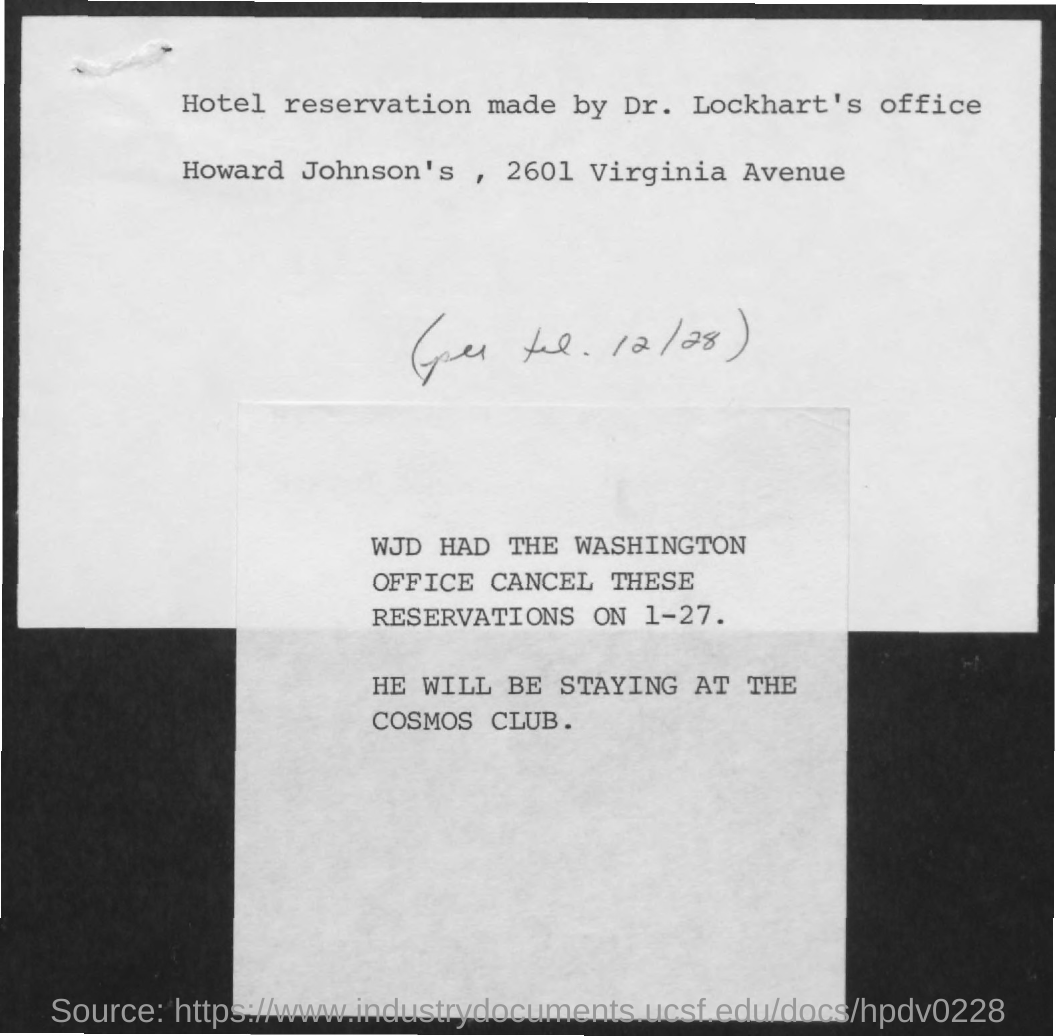Give some essential details in this illustration. The speaker is inquiring about the location where the person referred to as "he" will be staying, and provides the information that "he" will be staying at the Cosmos Club. The reservation was cancelled on January 27th. The reservation was made at Howard Johnson's, located at 2601 Virginia Avenue. The hotel reservation was made by Dr. Lockhart's office. 